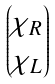Convert formula to latex. <formula><loc_0><loc_0><loc_500><loc_500>\begin{pmatrix} \chi _ { R } \\ \chi _ { L } \end{pmatrix}</formula> 